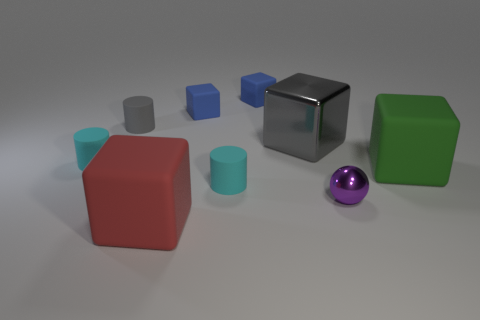There is a cylinder that is the same color as the shiny cube; what is its size?
Ensure brevity in your answer.  Small. What material is the tiny thing that is the same color as the metal block?
Keep it short and to the point. Rubber. How many blue objects are the same shape as the red matte thing?
Offer a very short reply. 2. Are there more tiny blue cubes in front of the small metallic ball than tiny brown rubber balls?
Make the answer very short. No. The cyan rubber object that is right of the small cyan object behind the large cube on the right side of the metallic block is what shape?
Give a very brief answer. Cylinder. There is a tiny cyan thing in front of the green object; is its shape the same as the cyan thing that is behind the green matte thing?
Offer a very short reply. Yes. Are there any other things that have the same size as the gray cube?
Your response must be concise. Yes. How many cylinders are either gray shiny objects or purple objects?
Provide a short and direct response. 0. Is the green block made of the same material as the purple object?
Your response must be concise. No. What number of other objects are the same color as the metal block?
Your answer should be compact. 1. 